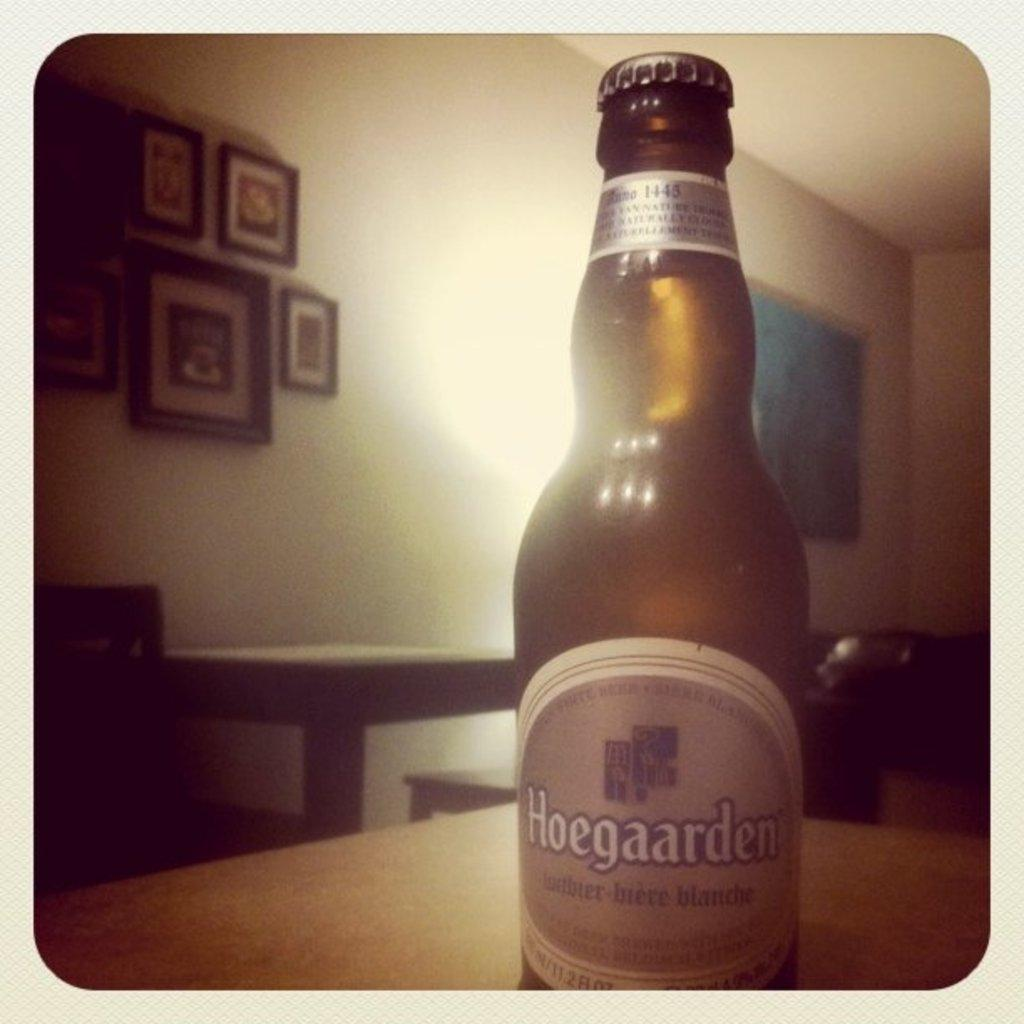<image>
Describe the image concisely. A bottle of Hoegaarden is sitting on a table with the cap still on. 